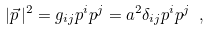Convert formula to latex. <formula><loc_0><loc_0><loc_500><loc_500>| \vec { p } \, | ^ { 2 } = g _ { i j } p ^ { i } p ^ { j } = a ^ { 2 } \delta _ { i j } p ^ { i } p ^ { j } \ ,</formula> 